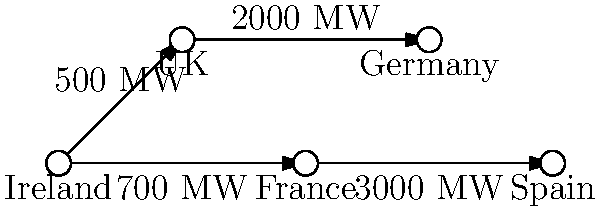Based on the network diagram representing electrical grid interconnections between Ireland and other European countries, which country has the highest direct transmission capacity with Ireland, and what is the total transmission capacity between Ireland and the continent (excluding the UK)? To answer this question, we need to analyze the network diagram step-by-step:

1. Identify Ireland's direct connections:
   - Ireland is connected to the UK with a capacity of 500 MW
   - Ireland is connected to France with a capacity of 700 MW

2. Determine the highest direct transmission capacity:
   - UK: 500 MW
   - France: 700 MW
   France has the highest direct transmission capacity with Ireland.

3. Calculate the total transmission capacity to the continent (excluding the UK):
   - The only direct connection to the continent is with France
   - The capacity of this connection is 700 MW

Therefore, France has the highest direct transmission capacity with Ireland at 700 MW, which is also the total transmission capacity between Ireland and the continent (excluding the UK).
Answer: France; 700 MW 